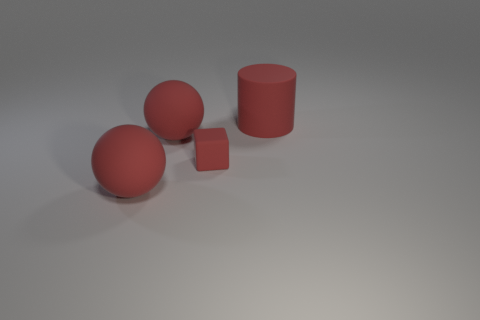Add 3 small purple rubber balls. How many objects exist? 7 Subtract all cubes. How many objects are left? 3 Subtract all small matte things. Subtract all purple metallic objects. How many objects are left? 3 Add 1 big red objects. How many big red objects are left? 4 Add 3 tiny red things. How many tiny red things exist? 4 Subtract 0 yellow blocks. How many objects are left? 4 